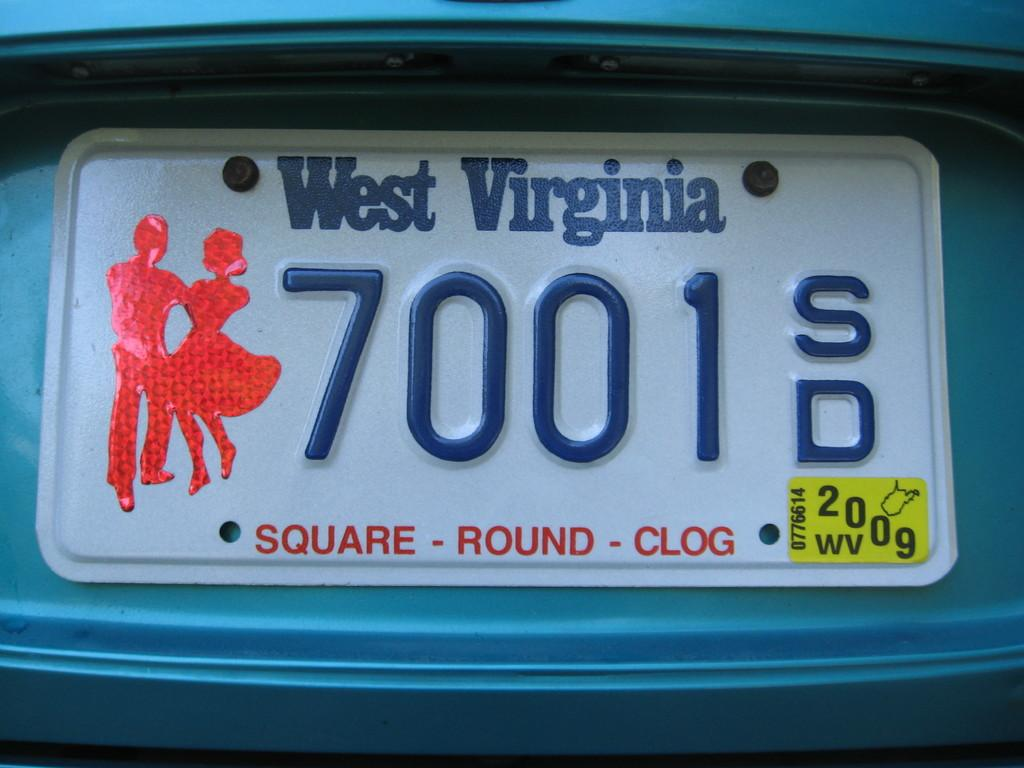<image>
Give a short and clear explanation of the subsequent image. White license plate for West Virginia which says 7001. 